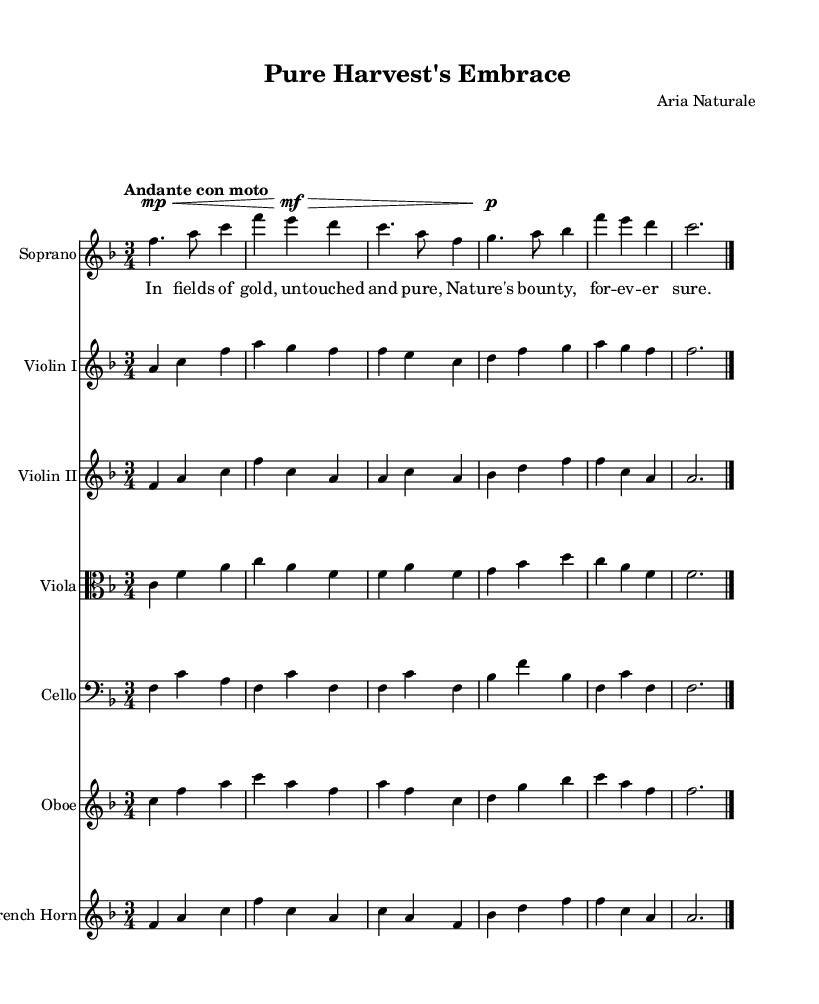What is the key signature of this music? The key signature indicates F major, which has one flat (B flat). This can be determined by looking at the key signature at the beginning of the score.
Answer: F major What is the time signature of this piece? The time signature is shown at the beginning right after the key signature, and it shows three beats per measure (3/4).
Answer: 3/4 What is the tempo marking of this score? The tempo marking is "Andante con moto," which conveys a moderately slow tempo with slight movement. This is indicated at the start of the score.
Answer: Andante con moto How many measures does the soprano staff contain? Counting the measures in the soprano staff, there are a total of 6 measures indicated by the vertical bar lines.
Answer: 6 Which instruments are included in the ensemble? The instruments listed in the score are Soprano, Violin I, Violin II, Viola, Cello, Oboe, and French Horn. Each is designated on its own staff in the score.
Answer: Soprano, Violin I, Violin II, Viola, Cello, Oboe, French Horn What mood or theme does the text of the piece suggest? The lyrics talk about untouched fields and nature’s bounty, suggesting a theme of purity and idyllic rural life, which reflects the opera's focus.
Answer: Purity and idyllic rural life What is the dynamics marking at the beginning of the soprano part? The dynamics marking in the soprano part starts with "mp" which stands for mezzo-piano, indicating a moderately soft volume. This is found at the beginning of the soprano line.
Answer: mezzo-piano 